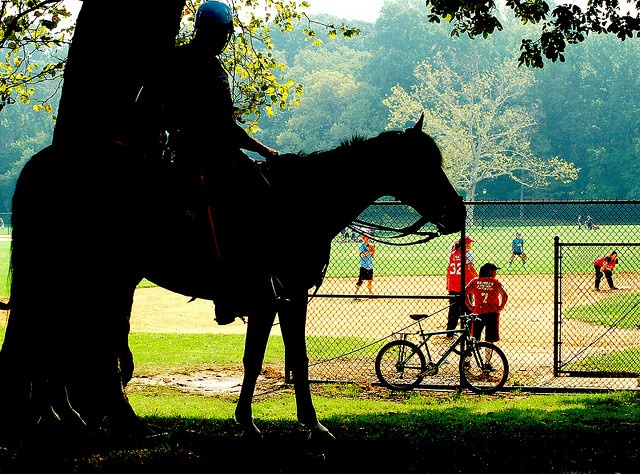Describe the objects in this image and their specific colors. I can see horse in lightyellow, black, teal, gray, and khaki tones, people in lightyellow, black, navy, blue, and gray tones, bicycle in lightyellow, black, khaki, beige, and olive tones, people in lightyellow, black, maroon, and red tones, and people in lightyellow, black, red, brown, and beige tones in this image. 